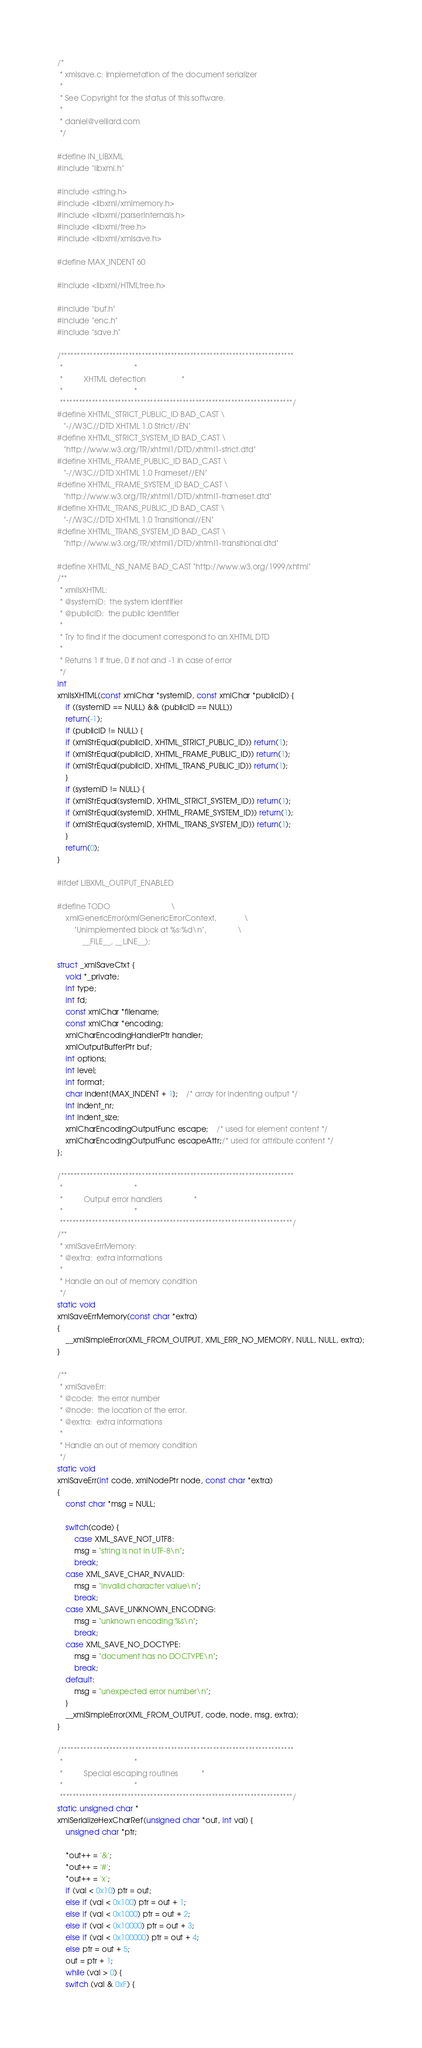Convert code to text. <code><loc_0><loc_0><loc_500><loc_500><_C_>/*
 * xmlsave.c: Implemetation of the document serializer
 *
 * See Copyright for the status of this software.
 *
 * daniel@veillard.com
 */

#define IN_LIBXML
#include "libxml.h"

#include <string.h>
#include <libxml/xmlmemory.h>
#include <libxml/parserInternals.h>
#include <libxml/tree.h>
#include <libxml/xmlsave.h>

#define MAX_INDENT 60

#include <libxml/HTMLtree.h>

#include "buf.h"
#include "enc.h"
#include "save.h"

/************************************************************************
 *									*
 *			XHTML detection					*
 *									*
 ************************************************************************/
#define XHTML_STRICT_PUBLIC_ID BAD_CAST \
   "-//W3C//DTD XHTML 1.0 Strict//EN"
#define XHTML_STRICT_SYSTEM_ID BAD_CAST \
   "http://www.w3.org/TR/xhtml1/DTD/xhtml1-strict.dtd"
#define XHTML_FRAME_PUBLIC_ID BAD_CAST \
   "-//W3C//DTD XHTML 1.0 Frameset//EN"
#define XHTML_FRAME_SYSTEM_ID BAD_CAST \
   "http://www.w3.org/TR/xhtml1/DTD/xhtml1-frameset.dtd"
#define XHTML_TRANS_PUBLIC_ID BAD_CAST \
   "-//W3C//DTD XHTML 1.0 Transitional//EN"
#define XHTML_TRANS_SYSTEM_ID BAD_CAST \
   "http://www.w3.org/TR/xhtml1/DTD/xhtml1-transitional.dtd"

#define XHTML_NS_NAME BAD_CAST "http://www.w3.org/1999/xhtml"
/**
 * xmlIsXHTML:
 * @systemID:  the system identifier
 * @publicID:  the public identifier
 *
 * Try to find if the document correspond to an XHTML DTD
 *
 * Returns 1 if true, 0 if not and -1 in case of error
 */
int
xmlIsXHTML(const xmlChar *systemID, const xmlChar *publicID) {
    if ((systemID == NULL) && (publicID == NULL))
	return(-1);
    if (publicID != NULL) {
	if (xmlStrEqual(publicID, XHTML_STRICT_PUBLIC_ID)) return(1);
	if (xmlStrEqual(publicID, XHTML_FRAME_PUBLIC_ID)) return(1);
	if (xmlStrEqual(publicID, XHTML_TRANS_PUBLIC_ID)) return(1);
    }
    if (systemID != NULL) {
	if (xmlStrEqual(systemID, XHTML_STRICT_SYSTEM_ID)) return(1);
	if (xmlStrEqual(systemID, XHTML_FRAME_SYSTEM_ID)) return(1);
	if (xmlStrEqual(systemID, XHTML_TRANS_SYSTEM_ID)) return(1);
    }
    return(0);
}

#ifdef LIBXML_OUTPUT_ENABLED

#define TODO								\
    xmlGenericError(xmlGenericErrorContext,				\
	    "Unimplemented block at %s:%d\n",				\
            __FILE__, __LINE__);

struct _xmlSaveCtxt {
    void *_private;
    int type;
    int fd;
    const xmlChar *filename;
    const xmlChar *encoding;
    xmlCharEncodingHandlerPtr handler;
    xmlOutputBufferPtr buf;
    int options;
    int level;
    int format;
    char indent[MAX_INDENT + 1];	/* array for indenting output */
    int indent_nr;
    int indent_size;
    xmlCharEncodingOutputFunc escape;	/* used for element content */
    xmlCharEncodingOutputFunc escapeAttr;/* used for attribute content */
};

/************************************************************************
 *									*
 *			Output error handlers				*
 *									*
 ************************************************************************/
/**
 * xmlSaveErrMemory:
 * @extra:  extra informations
 *
 * Handle an out of memory condition
 */
static void
xmlSaveErrMemory(const char *extra)
{
    __xmlSimpleError(XML_FROM_OUTPUT, XML_ERR_NO_MEMORY, NULL, NULL, extra);
}

/**
 * xmlSaveErr:
 * @code:  the error number
 * @node:  the location of the error.
 * @extra:  extra informations
 *
 * Handle an out of memory condition
 */
static void
xmlSaveErr(int code, xmlNodePtr node, const char *extra)
{
    const char *msg = NULL;

    switch(code) {
        case XML_SAVE_NOT_UTF8:
	    msg = "string is not in UTF-8\n";
	    break;
	case XML_SAVE_CHAR_INVALID:
	    msg = "invalid character value\n";
	    break;
	case XML_SAVE_UNKNOWN_ENCODING:
	    msg = "unknown encoding %s\n";
	    break;
	case XML_SAVE_NO_DOCTYPE:
	    msg = "document has no DOCTYPE\n";
	    break;
	default:
	    msg = "unexpected error number\n";
    }
    __xmlSimpleError(XML_FROM_OUTPUT, code, node, msg, extra);
}

/************************************************************************
 *									*
 *			Special escaping routines			*
 *									*
 ************************************************************************/
static unsigned char *
xmlSerializeHexCharRef(unsigned char *out, int val) {
    unsigned char *ptr;

    *out++ = '&';
    *out++ = '#';
    *out++ = 'x';
    if (val < 0x10) ptr = out;
    else if (val < 0x100) ptr = out + 1;
    else if (val < 0x1000) ptr = out + 2;
    else if (val < 0x10000) ptr = out + 3;
    else if (val < 0x100000) ptr = out + 4;
    else ptr = out + 5;
    out = ptr + 1;
    while (val > 0) {
	switch (val & 0xF) {</code> 